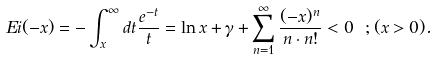<formula> <loc_0><loc_0><loc_500><loc_500>E i ( - x ) = - \int ^ { \infty } _ { x } d t \frac { e ^ { - t } } { t } = \ln x + \gamma + \sum ^ { \infty } _ { n = 1 } \frac { ( - x ) ^ { n } } { n \cdot n ! } < 0 \ ; ( x > 0 ) .</formula> 